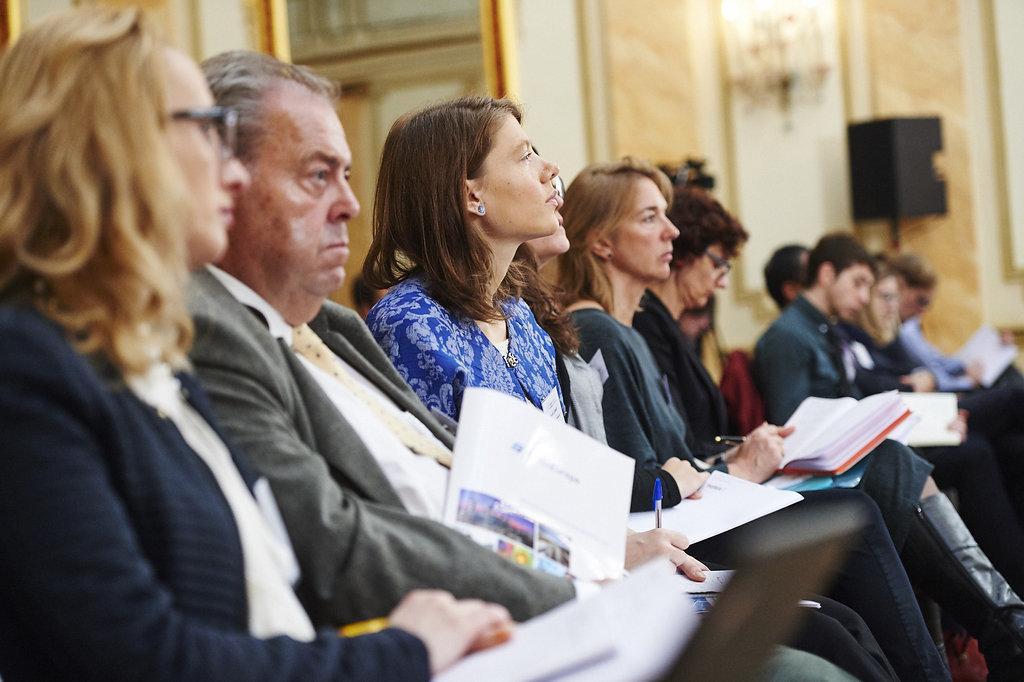Describe this image in one or two sentences. In this picture I can see few people seated and few are holding papers in their hands and few of them holding books and pens in their hands and I can see lights on the wall and a speaker and looks like few photo frames on the back. 